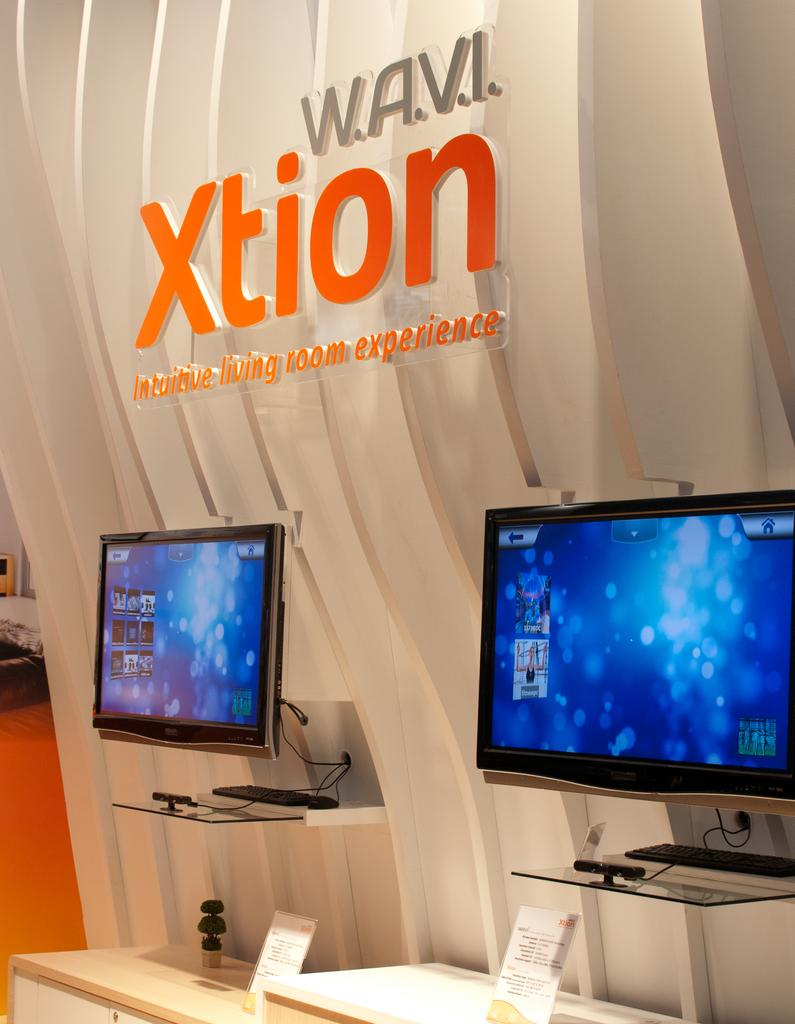<image>
Write a terse but informative summary of the picture. Monitors on display in front of a sign that says Xtion. 